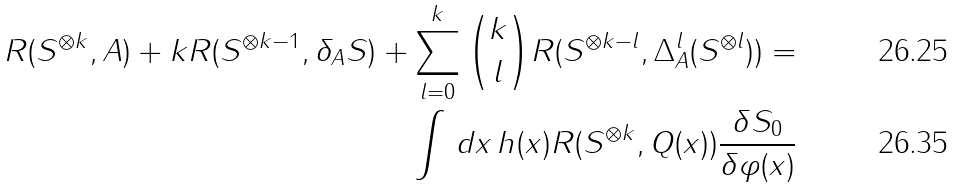<formula> <loc_0><loc_0><loc_500><loc_500>R ( S ^ { \otimes k } , A ) + k R ( S ^ { \otimes k - 1 } , \delta _ { A } S ) + \sum _ { l = 0 } ^ { k } \binom { k } { l } R ( S ^ { \otimes k - l } , \Delta ^ { l } _ { A } ( S ^ { \otimes l } ) ) = \\ \int \, d x \, h ( x ) R ( S ^ { \otimes k } , Q ( x ) ) \frac { \delta S _ { 0 } } { \delta \varphi ( x ) }</formula> 